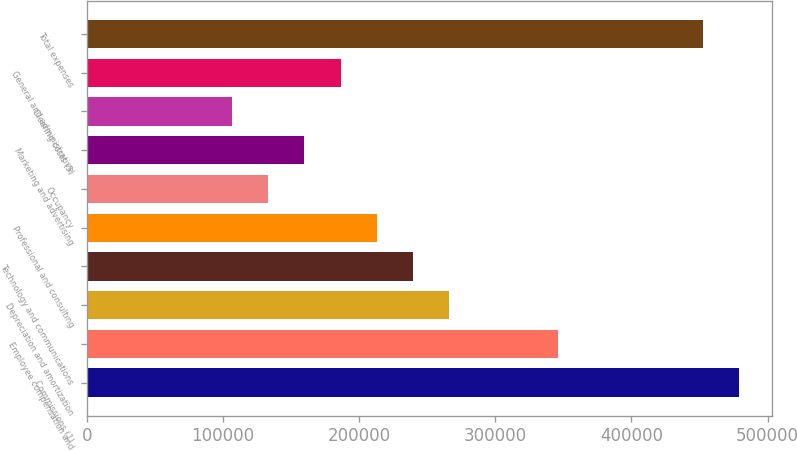Convert chart to OTSL. <chart><loc_0><loc_0><loc_500><loc_500><bar_chart><fcel>Commissions (1)<fcel>Employee compensation and<fcel>Depreciation and amortization<fcel>Technology and communications<fcel>Professional and consulting<fcel>Occupancy<fcel>Marketing and advertising<fcel>Clearing costs (5)<fcel>General and administrative<fcel>Total expenses<nl><fcel>479197<fcel>346087<fcel>266221<fcel>239599<fcel>212977<fcel>133111<fcel>159733<fcel>106489<fcel>186355<fcel>452575<nl></chart> 